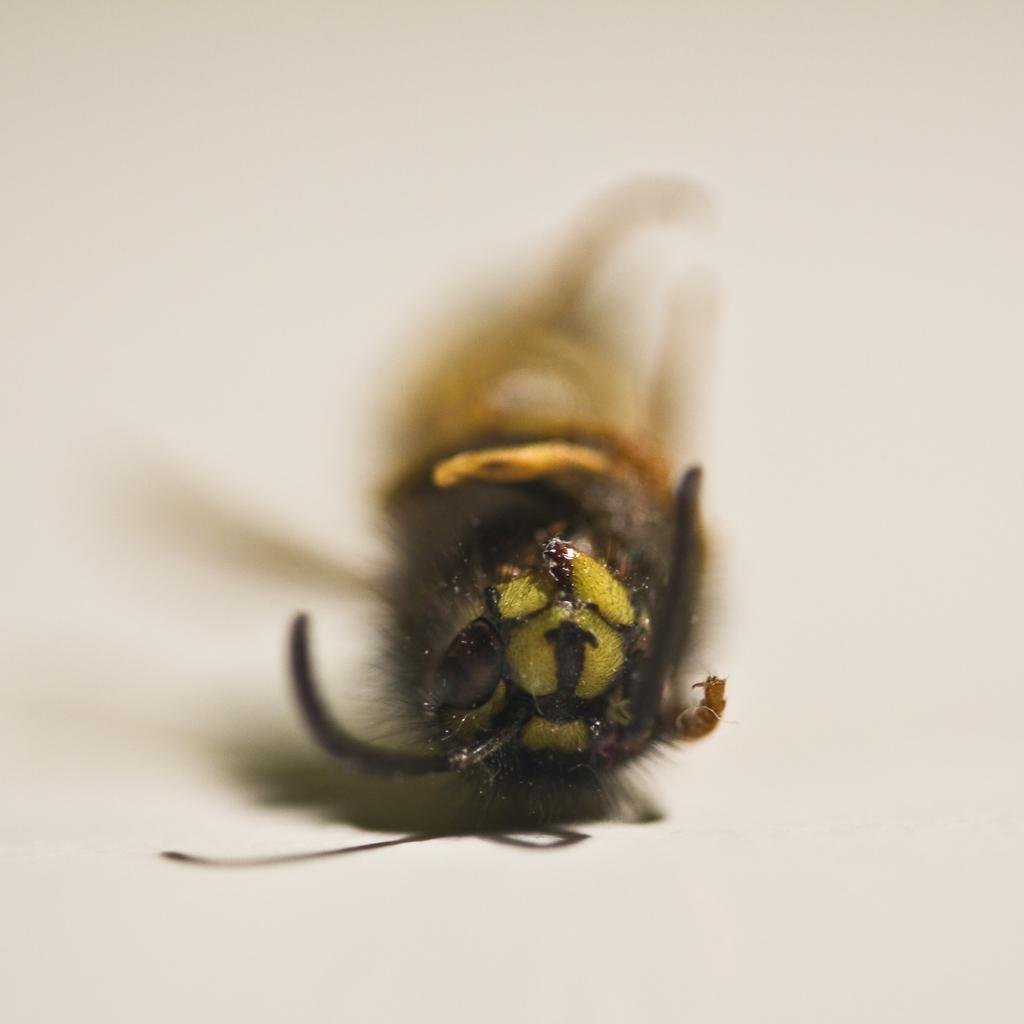What type of creature is in the image? There is an insect in the image. Where is the insect located? The insect is on a surface. What decision does the insect make in the image? There is no indication of the insect making a decision in the image. What type of cap is the insect wearing in the image? There is no cap present in the image, as insects do not wear clothing. 